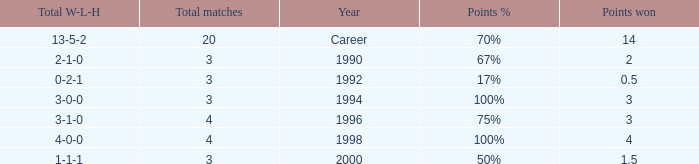Can you tell me the lowest Total natches that has the Points won of 3, and the Year of 1994? 3.0. 